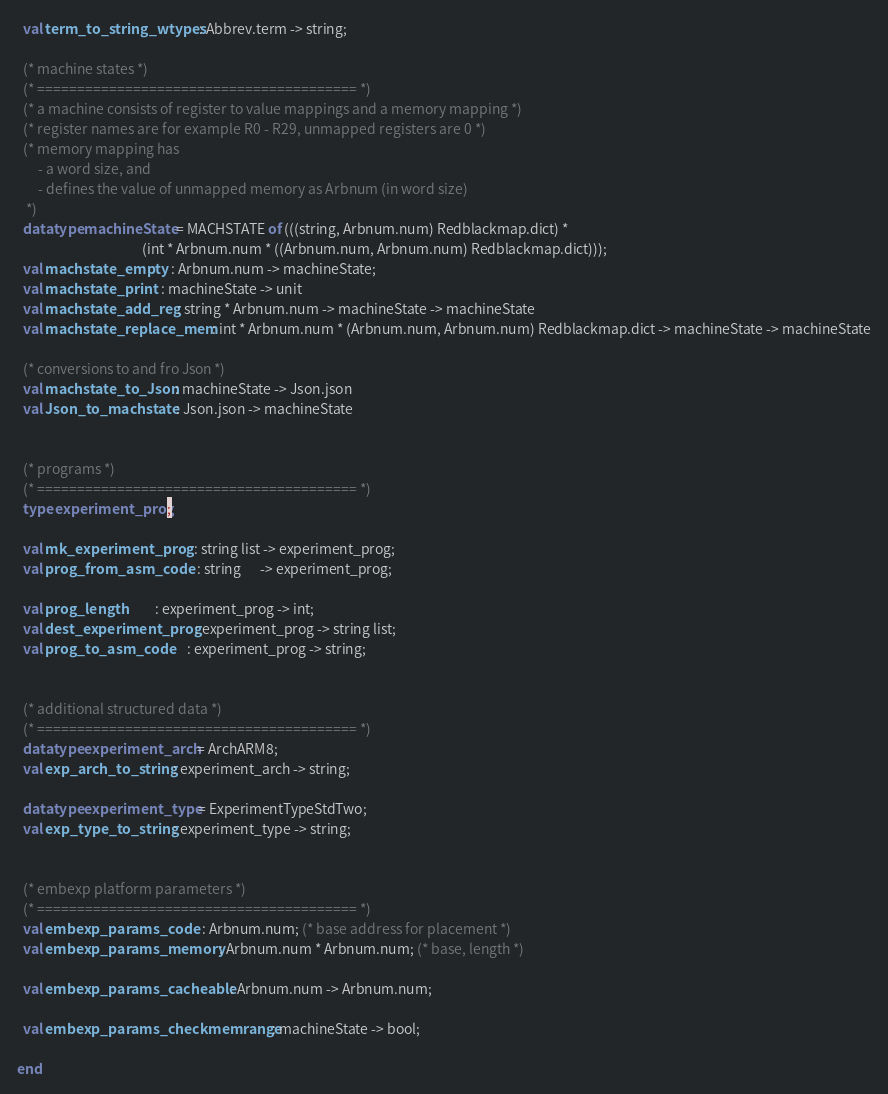Convert code to text. <code><loc_0><loc_0><loc_500><loc_500><_SML_>  val term_to_string_wtypes : Abbrev.term -> string;

  (* machine states *)
  (* ======================================== *)
  (* a machine consists of register to value mappings and a memory mapping *)
  (* register names are for example R0 - R29, unmapped registers are 0 *)
  (* memory mapping has
       - a word size, and
       - defines the value of unmapped memory as Arbnum (in word size)
   *)
  datatype machineState = MACHSTATE of (((string, Arbnum.num) Redblackmap.dict) *
                                        (int * Arbnum.num * ((Arbnum.num, Arbnum.num) Redblackmap.dict)));
  val machstate_empty   : Arbnum.num -> machineState;
  val machstate_print   : machineState -> unit
  val machstate_add_reg : string * Arbnum.num -> machineState -> machineState
  val machstate_replace_mem : int * Arbnum.num * (Arbnum.num, Arbnum.num) Redblackmap.dict -> machineState -> machineState

  (* conversions to and fro Json *)
  val machstate_to_Json : machineState -> Json.json
  val Json_to_machstate : Json.json -> machineState


  (* programs *)
  (* ======================================== *)
  type experiment_prog;

  val mk_experiment_prog   : string list -> experiment_prog;
  val prog_from_asm_code   : string      -> experiment_prog;

  val prog_length          : experiment_prog -> int;
  val dest_experiment_prog : experiment_prog -> string list;
  val prog_to_asm_code     : experiment_prog -> string;


  (* additional structured data *)
  (* ======================================== *)
  datatype experiment_arch = ArchARM8;
  val exp_arch_to_string : experiment_arch -> string;

  datatype experiment_type = ExperimentTypeStdTwo;
  val exp_type_to_string : experiment_type -> string;


  (* embexp platform parameters *)
  (* ======================================== *)
  val embexp_params_code   : Arbnum.num; (* base address for placement *)
  val embexp_params_memory : Arbnum.num * Arbnum.num; (* base, length *)

  val embexp_params_cacheable : Arbnum.num -> Arbnum.num;

  val embexp_params_checkmemrange : machineState -> bool;

end
</code> 